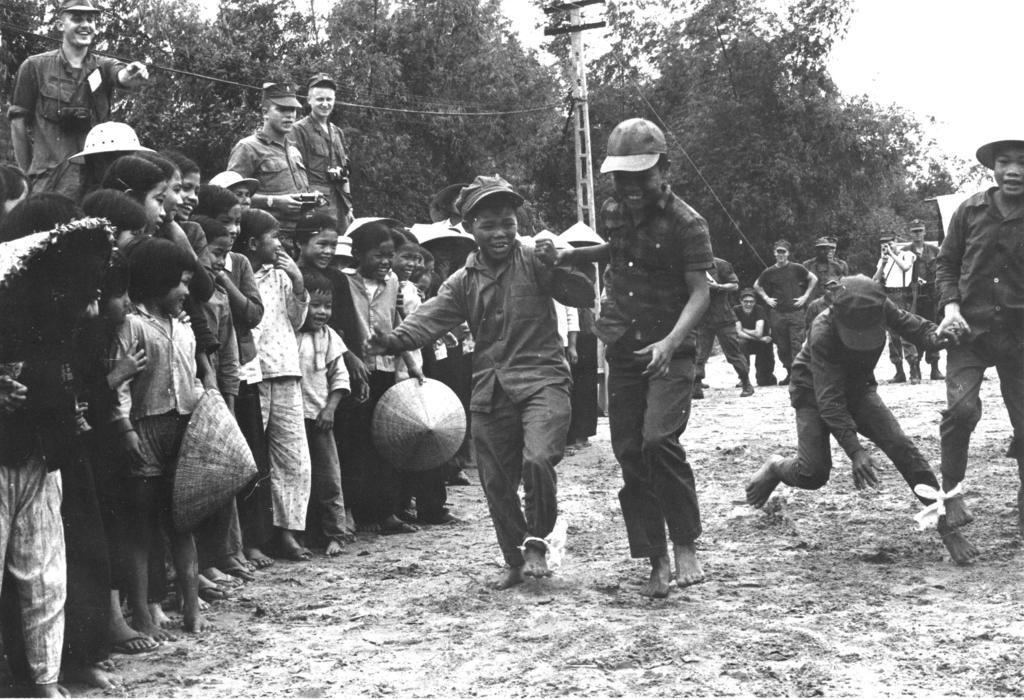How would you summarize this image in a sentence or two? In the image we can see there are people standing on the ground and they are wearing caps. There are lot of trees at the back and the image is in black and white colour. 